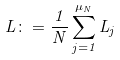<formula> <loc_0><loc_0><loc_500><loc_500>L \colon = \frac { 1 } { N } \sum _ { j = 1 } ^ { \mu _ { N } } L _ { j }</formula> 